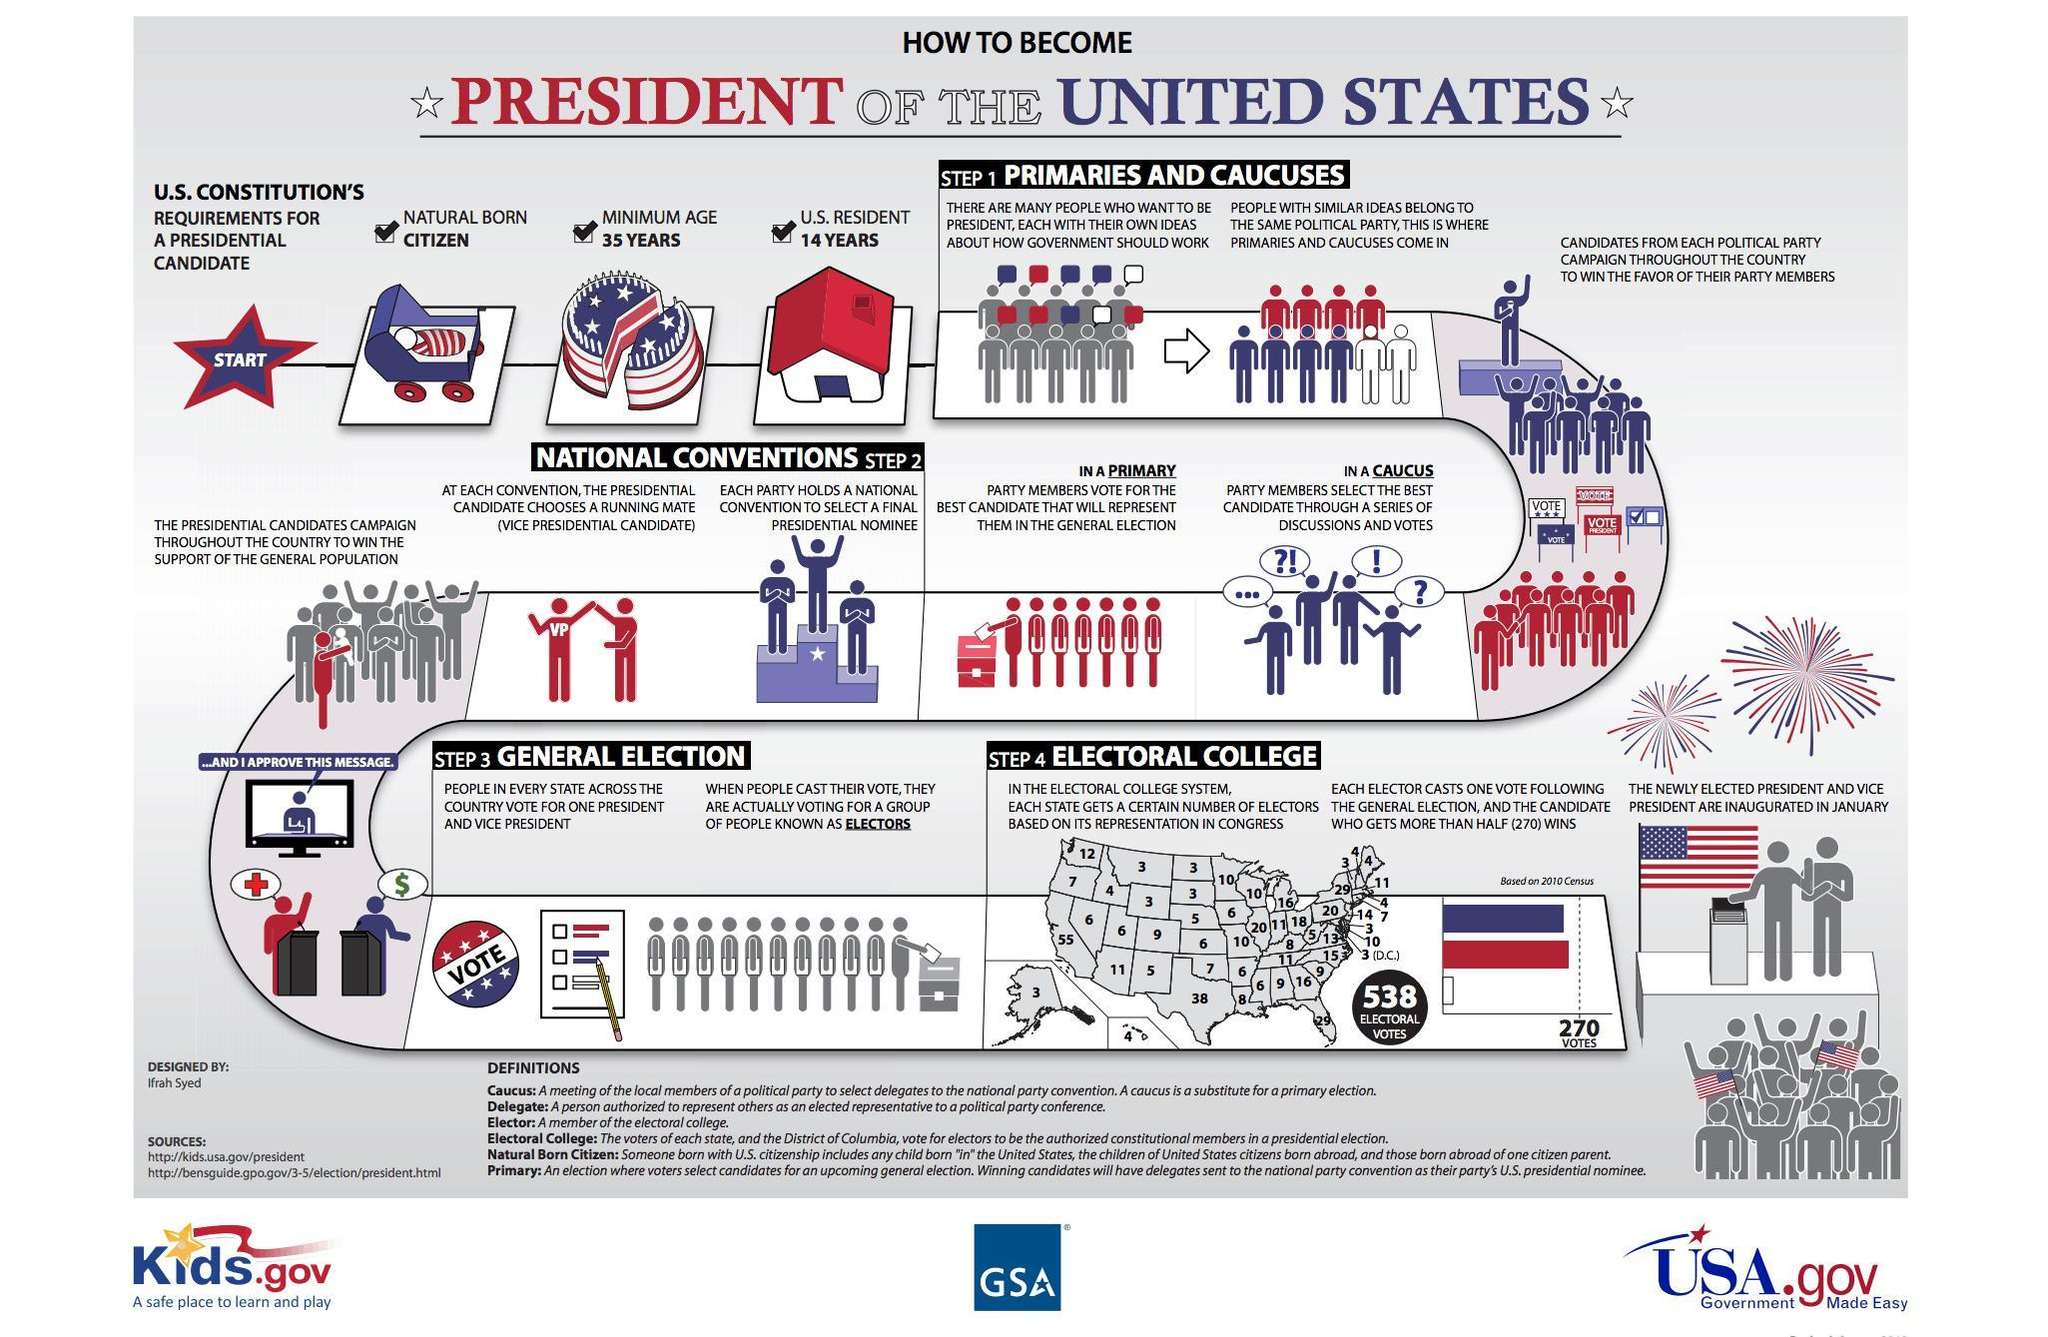Which is the third step in the election process ?
Answer the question with a short phrase. General election Which is the final step in the election process? Electoral college How many requirements are mandated as per US constitution for a Presidential candidate? 3 Which is the second step in the election process? National Conventions How many methods are chosen to select the best candidate? 2 What are the methods used to choose select the best candidates? PRIMARIES AND CAUCUSES 